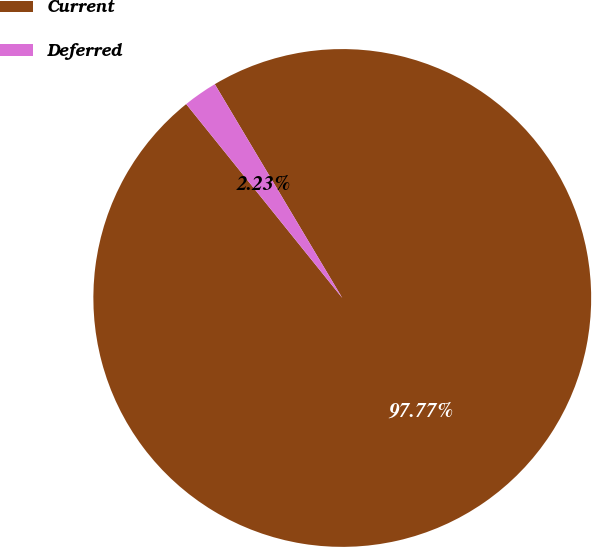Convert chart. <chart><loc_0><loc_0><loc_500><loc_500><pie_chart><fcel>Current<fcel>Deferred<nl><fcel>97.77%<fcel>2.23%<nl></chart> 